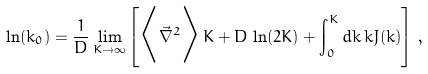Convert formula to latex. <formula><loc_0><loc_0><loc_500><loc_500>\ln ( k _ { 0 } ) = \frac { 1 } { D } \lim _ { K \to \infty } \left [ \Big < { \vec { \nabla } } ^ { 2 } \Big > \, K + D \, \ln ( 2 K ) + \int _ { 0 } ^ { K } d k \, k J ( k ) \right ] \, ,</formula> 